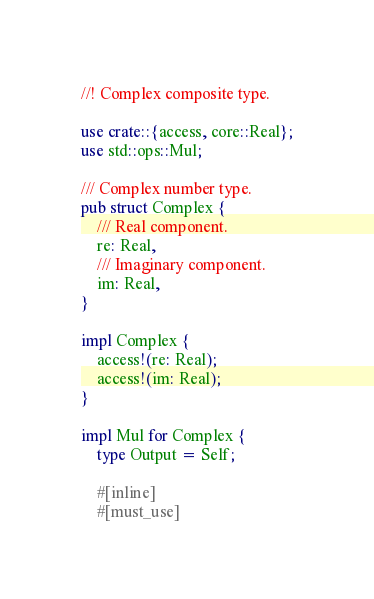Convert code to text. <code><loc_0><loc_0><loc_500><loc_500><_Rust_>//! Complex composite type.

use crate::{access, core::Real};
use std::ops::Mul;

/// Complex number type.
pub struct Complex {
    /// Real component.
    re: Real,
    /// Imaginary component.
    im: Real,
}

impl Complex {
    access!(re: Real);
    access!(im: Real);
}

impl Mul for Complex {
    type Output = Self;

    #[inline]
    #[must_use]</code> 